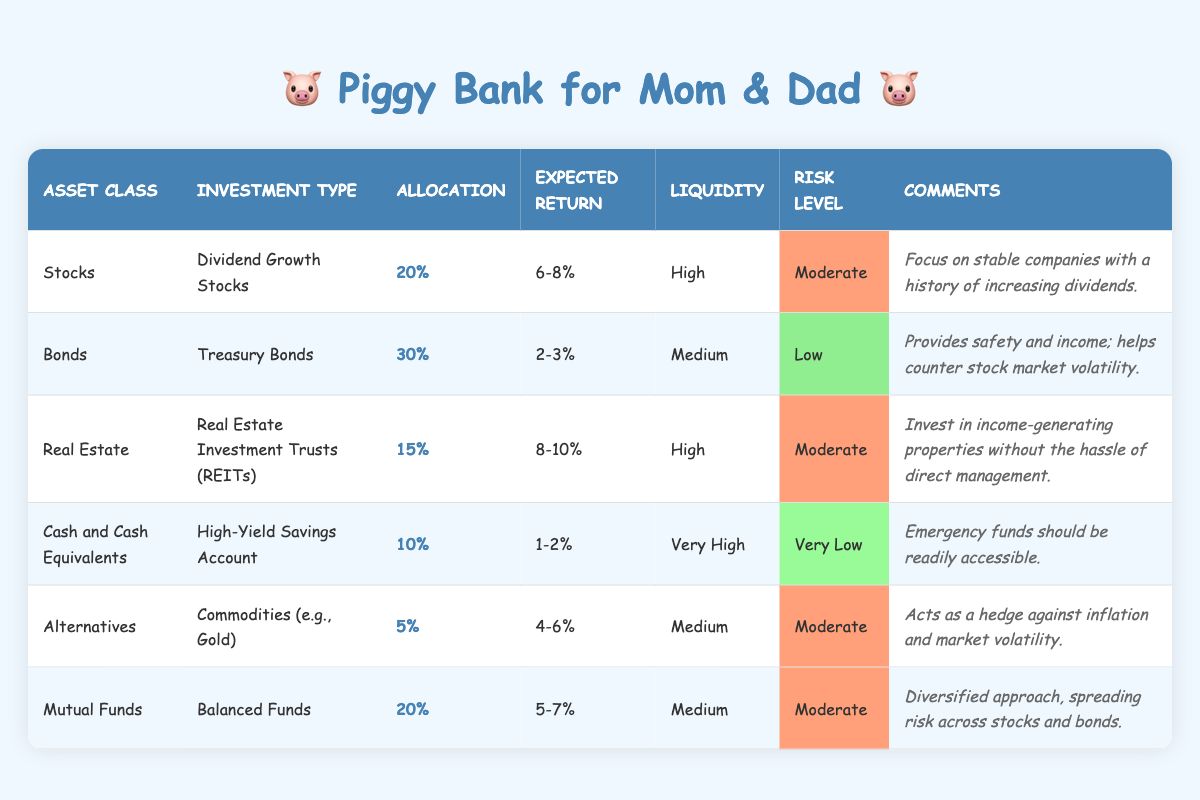What is the highest expected return in the investment portfolio allocation? The highest expected return is 8-10%, which corresponds to Real Estate Investment Trusts (REITs).
Answer: 8-10% What percentage of the portfolio is allocated to Bonds? The table shows that Bonds have a percentage allocation of 30%.
Answer: 30% Are Cash and Cash Equivalents considered a high-risk investment? No, Cash and Cash Equivalents are classified as having a Risk Level of Very Low according to the table.
Answer: No What is the total percentage allocation of Stocks and Mutual Funds combined? The allocation for Stocks is 20% and for Mutual Funds is also 20%. Thus, adding them together: 20% + 20% = 40%.
Answer: 40% Is the liquidity of Real Estate Investment Trusts (REITs) categorized as Very High? No, REITs have a liquidity classified as High, not Very High.
Answer: No What is the average expected return of the asset classes in the portfolio? The expected returns for each asset class are summarized as follows: Stocks (7%), Bonds (2.5%), REITs (9%), Cash (1.5%), Commodities (5%), and Mutual Funds (6%). Adding these returns gives a total of 31.5%. There are six asset classes, so the average return is 31.5% / 6 = 5.25%.
Answer: 5.25% Which asset class has the lowest expected return? Cash and Cash Equivalents have the lowest expected return range of 1-2%.
Answer: 1-2% How many asset classes have a moderate risk level? Looking at the table, the asset classes with a moderate risk level include Dividend Growth Stocks, Real Estate Investment Trusts (REITs), Commodities, and Balanced Funds, which totals to four asset classes.
Answer: 4 What is the liquidity category for Treasury Bonds? Treasury Bonds are classified with a liquidity level of Medium according to the table.
Answer: Medium 